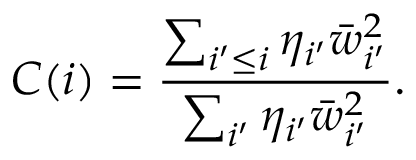<formula> <loc_0><loc_0><loc_500><loc_500>C ( i ) = \frac { \sum _ { i ^ { \prime } \leq i } \eta _ { i ^ { \prime } } \bar { w } _ { i ^ { \prime } } ^ { 2 } } { \sum _ { i ^ { \prime } } \eta _ { i ^ { \prime } } \bar { w } _ { i ^ { \prime } } ^ { 2 } } .</formula> 